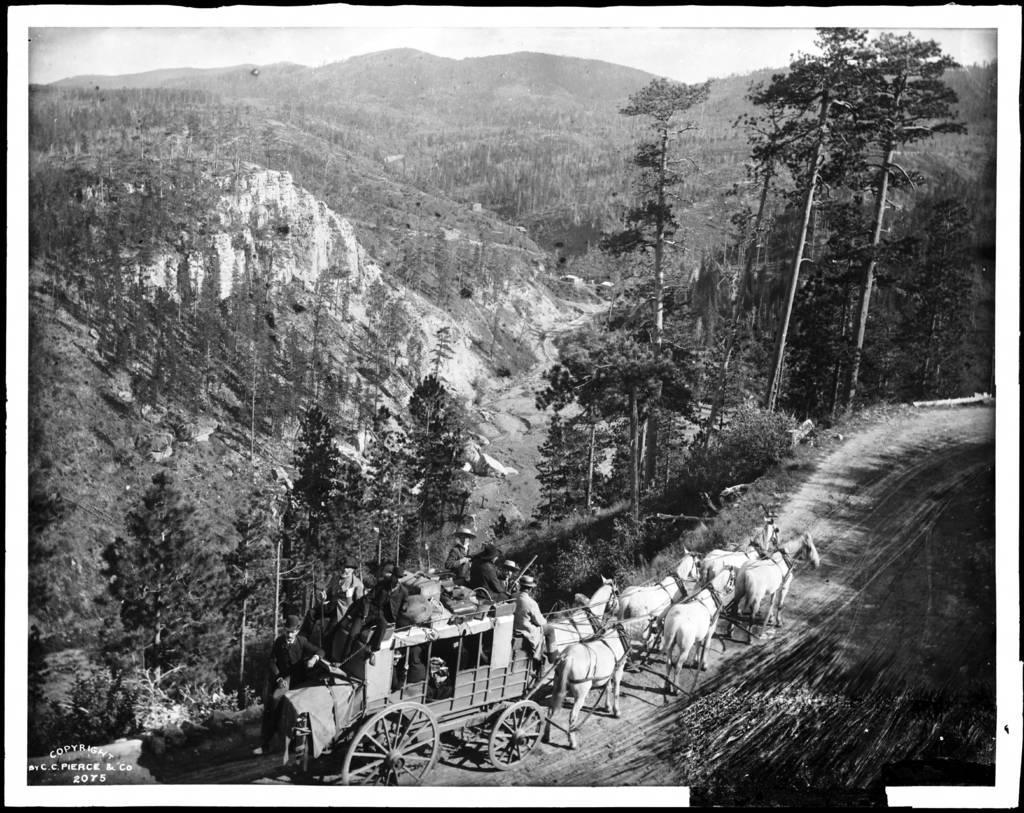Please provide a concise description of this image. This is an edited image with the borders and in the foreground we can see the horse car in which we can see the persons. In the background there is a sky, hills and trees. At the bottom left corner there is a text on the image. 